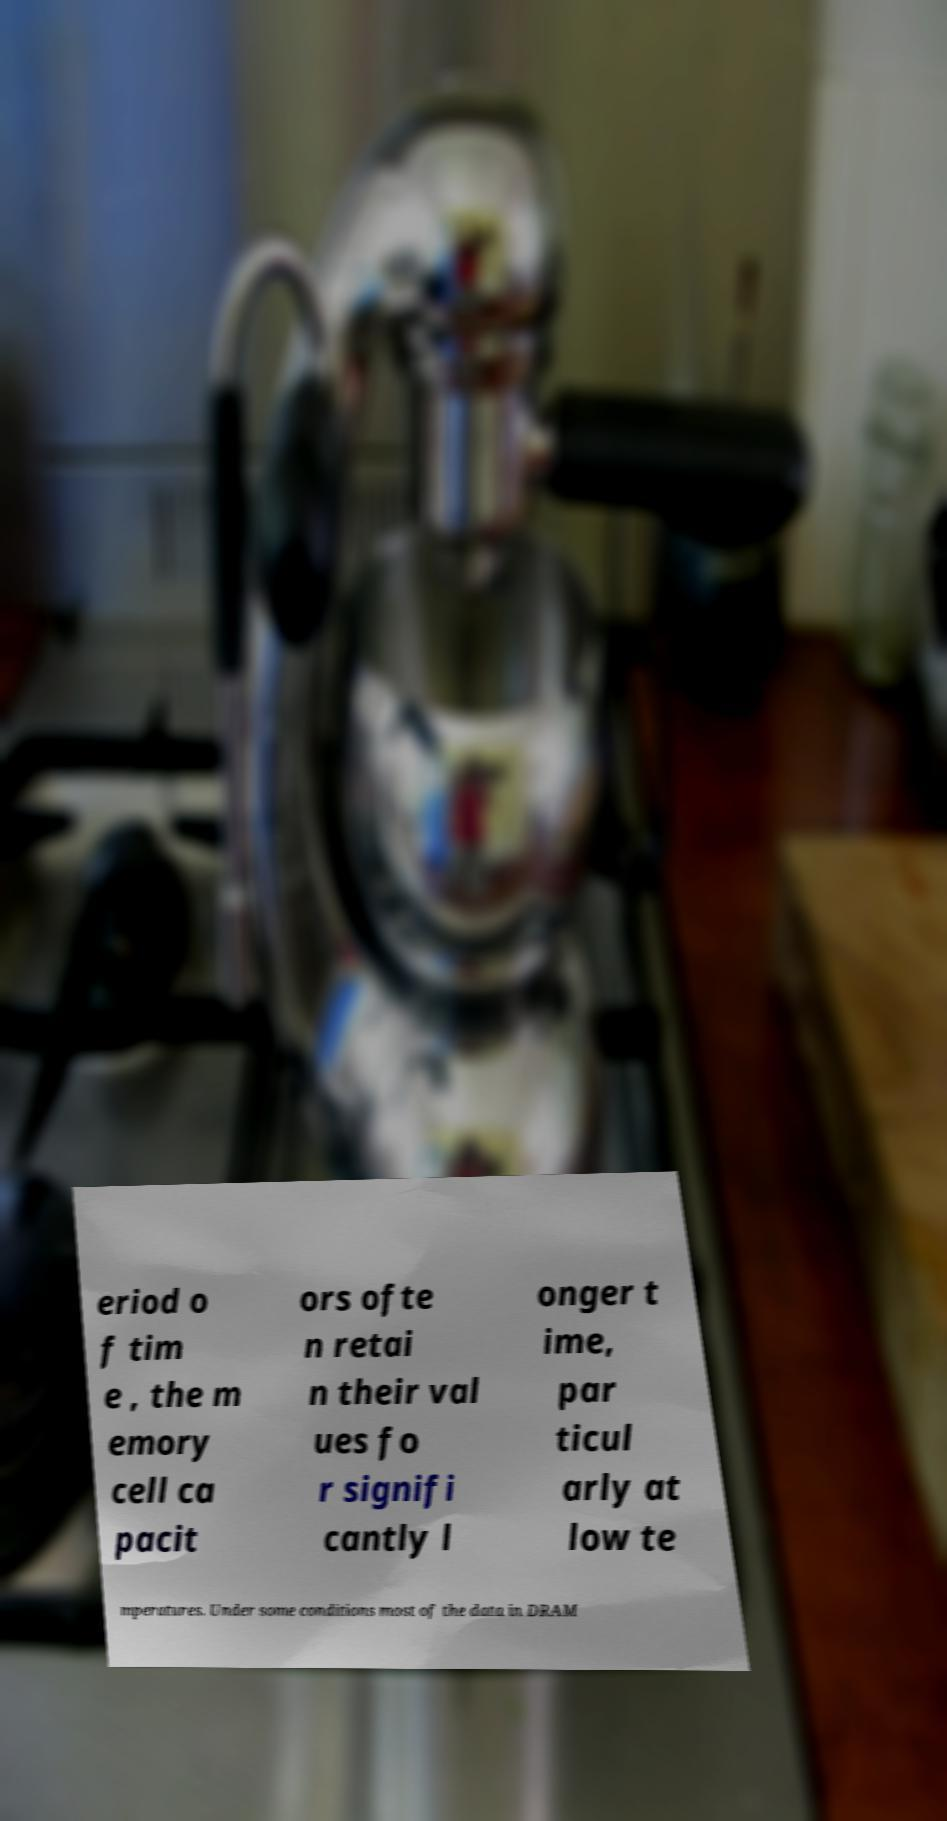Can you accurately transcribe the text from the provided image for me? eriod o f tim e , the m emory cell ca pacit ors ofte n retai n their val ues fo r signifi cantly l onger t ime, par ticul arly at low te mperatures. Under some conditions most of the data in DRAM 